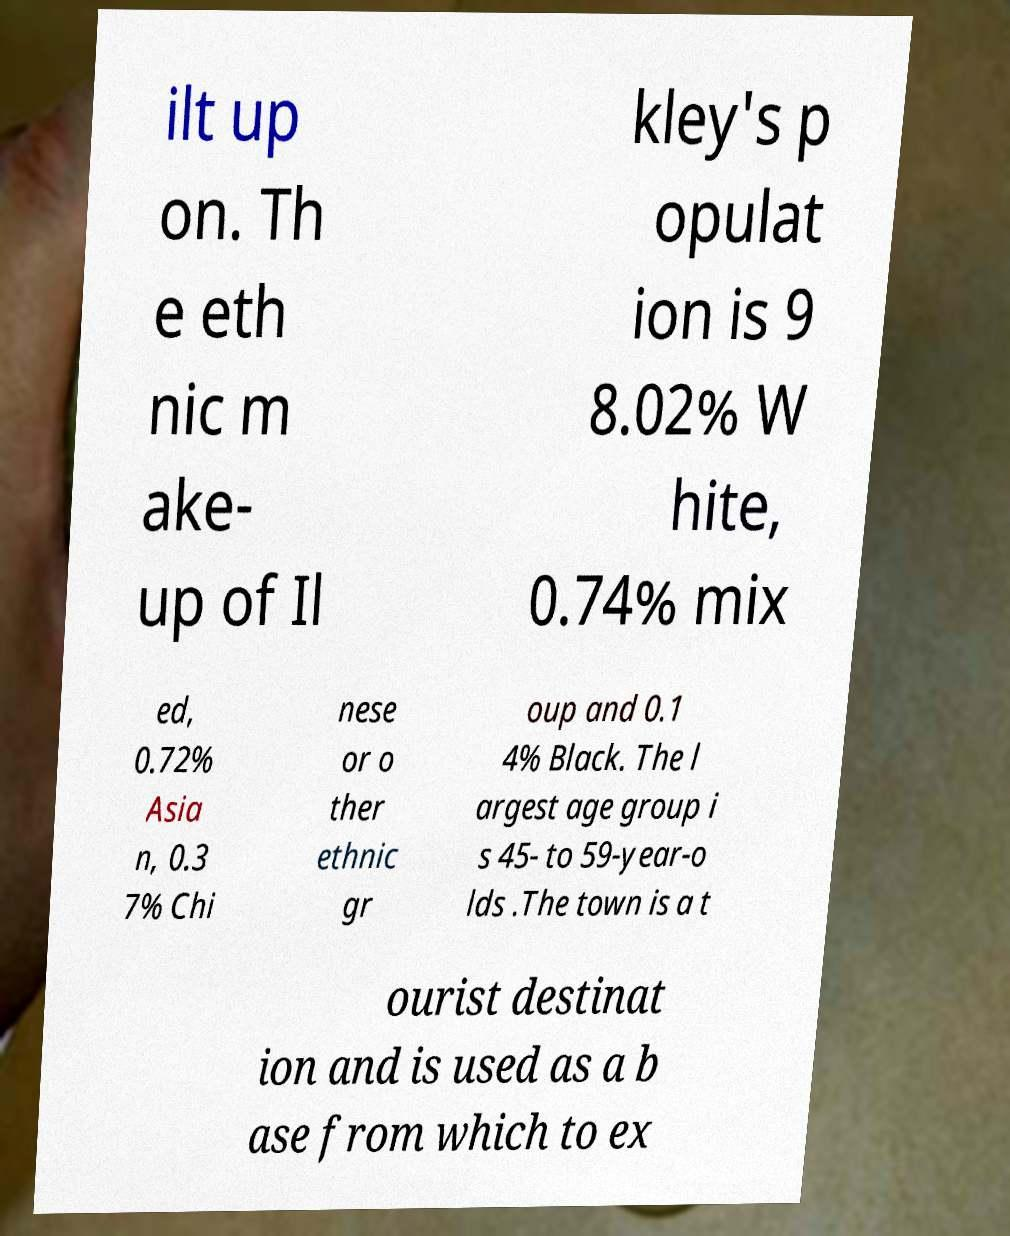Could you assist in decoding the text presented in this image and type it out clearly? ilt up on. Th e eth nic m ake- up of Il kley's p opulat ion is 9 8.02% W hite, 0.74% mix ed, 0.72% Asia n, 0.3 7% Chi nese or o ther ethnic gr oup and 0.1 4% Black. The l argest age group i s 45- to 59-year-o lds .The town is a t ourist destinat ion and is used as a b ase from which to ex 